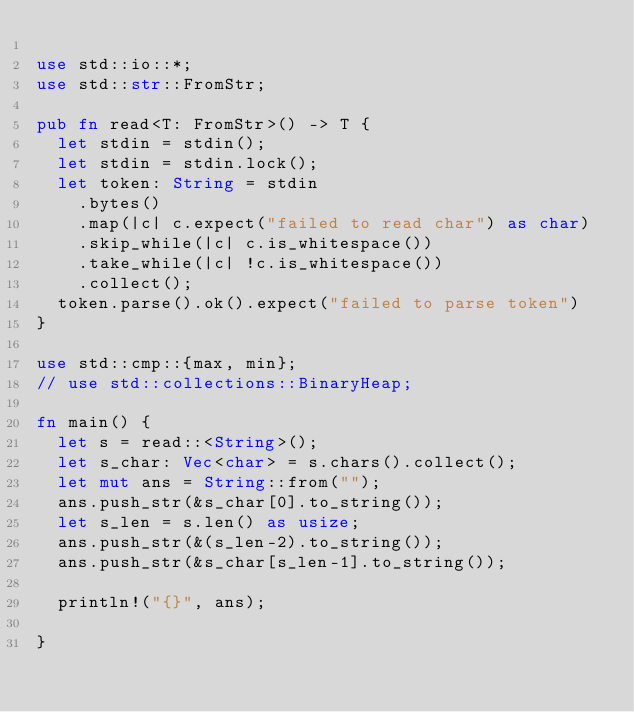<code> <loc_0><loc_0><loc_500><loc_500><_Rust_>
use std::io::*;
use std::str::FromStr;

pub fn read<T: FromStr>() -> T {
  let stdin = stdin();
  let stdin = stdin.lock();
  let token: String = stdin
    .bytes()
    .map(|c| c.expect("failed to read char") as char)
    .skip_while(|c| c.is_whitespace())
    .take_while(|c| !c.is_whitespace())
    .collect();
  token.parse().ok().expect("failed to parse token")
}

use std::cmp::{max, min};
// use std::collections::BinaryHeap;

fn main() {
  let s = read::<String>();
  let s_char: Vec<char> = s.chars().collect();
  let mut ans = String::from("");
  ans.push_str(&s_char[0].to_string());
  let s_len = s.len() as usize;
  ans.push_str(&(s_len-2).to_string());
  ans.push_str(&s_char[s_len-1].to_string());

  println!("{}", ans);

}
</code> 